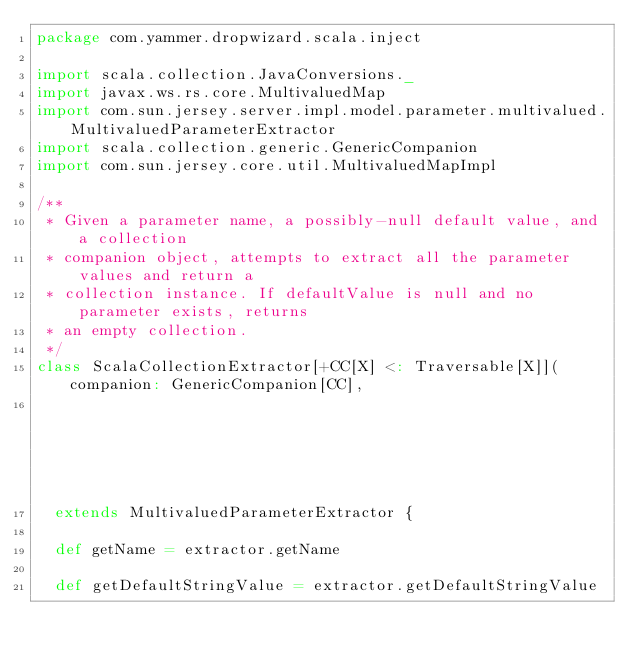<code> <loc_0><loc_0><loc_500><loc_500><_Scala_>package com.yammer.dropwizard.scala.inject

import scala.collection.JavaConversions._
import javax.ws.rs.core.MultivaluedMap
import com.sun.jersey.server.impl.model.parameter.multivalued.MultivaluedParameterExtractor
import scala.collection.generic.GenericCompanion
import com.sun.jersey.core.util.MultivaluedMapImpl

/**
 * Given a parameter name, a possibly-null default value, and a collection
 * companion object, attempts to extract all the parameter values and return a
 * collection instance. If defaultValue is null and no parameter exists, returns
 * an empty collection.
 */
class ScalaCollectionExtractor[+CC[X] <: Traversable[X]](companion: GenericCompanion[CC],
                                                                     extractor: MultivaluedParameterExtractor)
  extends MultivaluedParameterExtractor {

  def getName = extractor.getName

  def getDefaultStringValue = extractor.getDefaultStringValue
</code> 